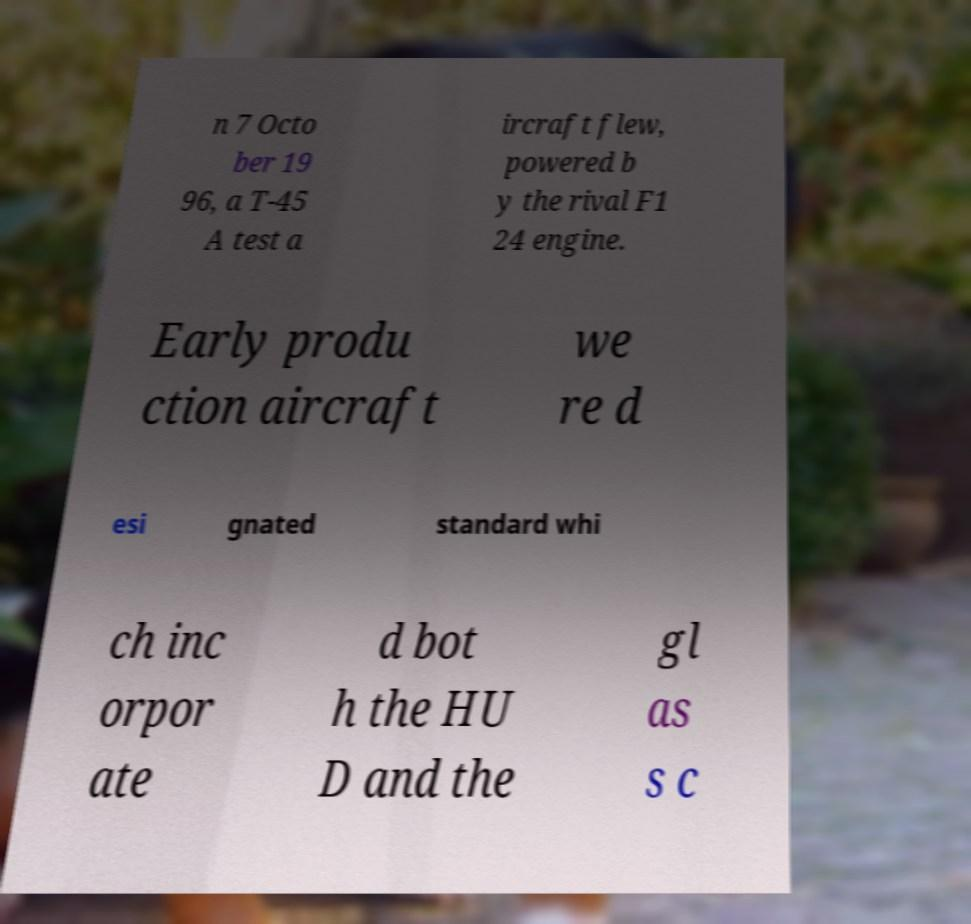Please read and relay the text visible in this image. What does it say? n 7 Octo ber 19 96, a T-45 A test a ircraft flew, powered b y the rival F1 24 engine. Early produ ction aircraft we re d esi gnated standard whi ch inc orpor ate d bot h the HU D and the gl as s c 